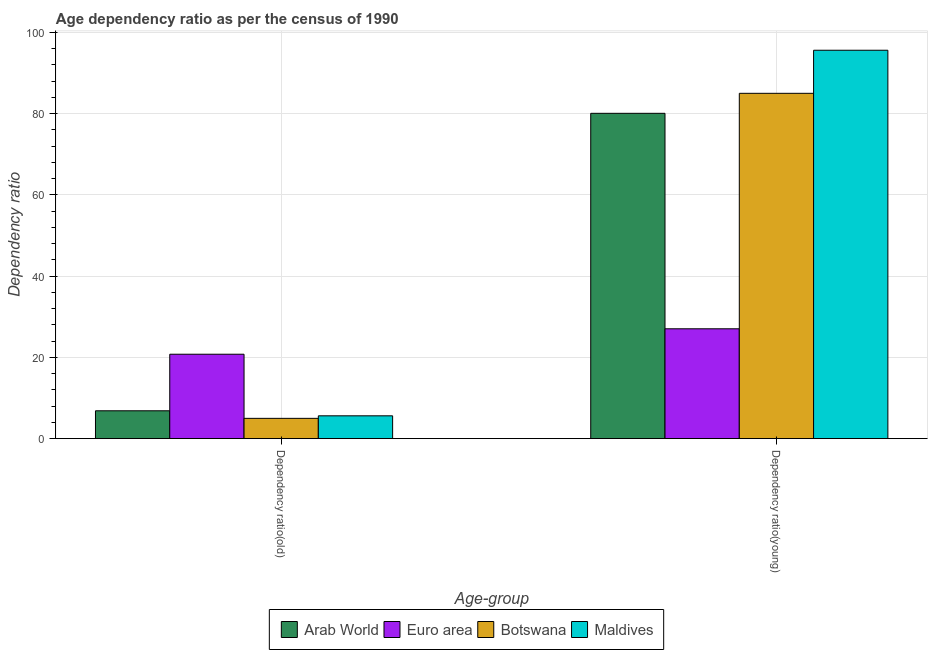How many different coloured bars are there?
Your response must be concise. 4. Are the number of bars on each tick of the X-axis equal?
Your response must be concise. Yes. How many bars are there on the 1st tick from the left?
Your response must be concise. 4. What is the label of the 2nd group of bars from the left?
Keep it short and to the point. Dependency ratio(young). What is the age dependency ratio(young) in Botswana?
Keep it short and to the point. 85.01. Across all countries, what is the maximum age dependency ratio(young)?
Ensure brevity in your answer.  95.61. Across all countries, what is the minimum age dependency ratio(young)?
Your answer should be very brief. 27.04. In which country was the age dependency ratio(old) maximum?
Provide a short and direct response. Euro area. What is the total age dependency ratio(young) in the graph?
Make the answer very short. 287.75. What is the difference between the age dependency ratio(young) in Botswana and that in Maldives?
Provide a short and direct response. -10.61. What is the difference between the age dependency ratio(old) in Botswana and the age dependency ratio(young) in Euro area?
Provide a succinct answer. -22.05. What is the average age dependency ratio(old) per country?
Your answer should be very brief. 9.56. What is the difference between the age dependency ratio(old) and age dependency ratio(young) in Botswana?
Provide a short and direct response. -80.02. In how many countries, is the age dependency ratio(young) greater than 56 ?
Your answer should be very brief. 3. What is the ratio of the age dependency ratio(old) in Arab World to that in Maldives?
Offer a terse response. 1.22. In how many countries, is the age dependency ratio(old) greater than the average age dependency ratio(old) taken over all countries?
Offer a terse response. 1. What does the 1st bar from the left in Dependency ratio(old) represents?
Offer a very short reply. Arab World. What does the 2nd bar from the right in Dependency ratio(old) represents?
Your response must be concise. Botswana. How many bars are there?
Your answer should be compact. 8. Are all the bars in the graph horizontal?
Ensure brevity in your answer.  No. How many countries are there in the graph?
Make the answer very short. 4. Does the graph contain grids?
Offer a very short reply. Yes. Where does the legend appear in the graph?
Your response must be concise. Bottom center. How many legend labels are there?
Offer a very short reply. 4. How are the legend labels stacked?
Make the answer very short. Horizontal. What is the title of the graph?
Provide a short and direct response. Age dependency ratio as per the census of 1990. Does "Lao PDR" appear as one of the legend labels in the graph?
Offer a terse response. No. What is the label or title of the X-axis?
Keep it short and to the point. Age-group. What is the label or title of the Y-axis?
Give a very brief answer. Dependency ratio. What is the Dependency ratio in Arab World in Dependency ratio(old)?
Give a very brief answer. 6.85. What is the Dependency ratio of Euro area in Dependency ratio(old)?
Give a very brief answer. 20.78. What is the Dependency ratio of Botswana in Dependency ratio(old)?
Your answer should be compact. 4.99. What is the Dependency ratio of Maldives in Dependency ratio(old)?
Provide a short and direct response. 5.61. What is the Dependency ratio of Arab World in Dependency ratio(young)?
Make the answer very short. 80.09. What is the Dependency ratio in Euro area in Dependency ratio(young)?
Offer a very short reply. 27.04. What is the Dependency ratio of Botswana in Dependency ratio(young)?
Ensure brevity in your answer.  85.01. What is the Dependency ratio in Maldives in Dependency ratio(young)?
Your answer should be very brief. 95.61. Across all Age-group, what is the maximum Dependency ratio in Arab World?
Provide a succinct answer. 80.09. Across all Age-group, what is the maximum Dependency ratio of Euro area?
Make the answer very short. 27.04. Across all Age-group, what is the maximum Dependency ratio in Botswana?
Ensure brevity in your answer.  85.01. Across all Age-group, what is the maximum Dependency ratio of Maldives?
Make the answer very short. 95.61. Across all Age-group, what is the minimum Dependency ratio of Arab World?
Ensure brevity in your answer.  6.85. Across all Age-group, what is the minimum Dependency ratio in Euro area?
Offer a terse response. 20.78. Across all Age-group, what is the minimum Dependency ratio of Botswana?
Give a very brief answer. 4.99. Across all Age-group, what is the minimum Dependency ratio in Maldives?
Your response must be concise. 5.61. What is the total Dependency ratio of Arab World in the graph?
Offer a terse response. 86.94. What is the total Dependency ratio in Euro area in the graph?
Give a very brief answer. 47.81. What is the total Dependency ratio in Botswana in the graph?
Provide a short and direct response. 90. What is the total Dependency ratio in Maldives in the graph?
Your answer should be very brief. 101.23. What is the difference between the Dependency ratio in Arab World in Dependency ratio(old) and that in Dependency ratio(young)?
Offer a terse response. -73.23. What is the difference between the Dependency ratio in Euro area in Dependency ratio(old) and that in Dependency ratio(young)?
Give a very brief answer. -6.26. What is the difference between the Dependency ratio of Botswana in Dependency ratio(old) and that in Dependency ratio(young)?
Offer a terse response. -80.02. What is the difference between the Dependency ratio in Maldives in Dependency ratio(old) and that in Dependency ratio(young)?
Keep it short and to the point. -90. What is the difference between the Dependency ratio in Arab World in Dependency ratio(old) and the Dependency ratio in Euro area in Dependency ratio(young)?
Provide a succinct answer. -20.19. What is the difference between the Dependency ratio of Arab World in Dependency ratio(old) and the Dependency ratio of Botswana in Dependency ratio(young)?
Make the answer very short. -78.16. What is the difference between the Dependency ratio in Arab World in Dependency ratio(old) and the Dependency ratio in Maldives in Dependency ratio(young)?
Your response must be concise. -88.76. What is the difference between the Dependency ratio in Euro area in Dependency ratio(old) and the Dependency ratio in Botswana in Dependency ratio(young)?
Your answer should be very brief. -64.23. What is the difference between the Dependency ratio in Euro area in Dependency ratio(old) and the Dependency ratio in Maldives in Dependency ratio(young)?
Make the answer very short. -74.84. What is the difference between the Dependency ratio of Botswana in Dependency ratio(old) and the Dependency ratio of Maldives in Dependency ratio(young)?
Your response must be concise. -90.63. What is the average Dependency ratio of Arab World per Age-group?
Give a very brief answer. 43.47. What is the average Dependency ratio in Euro area per Age-group?
Make the answer very short. 23.91. What is the average Dependency ratio in Botswana per Age-group?
Your answer should be very brief. 45. What is the average Dependency ratio of Maldives per Age-group?
Your response must be concise. 50.61. What is the difference between the Dependency ratio in Arab World and Dependency ratio in Euro area in Dependency ratio(old)?
Your answer should be very brief. -13.92. What is the difference between the Dependency ratio of Arab World and Dependency ratio of Botswana in Dependency ratio(old)?
Your response must be concise. 1.86. What is the difference between the Dependency ratio in Arab World and Dependency ratio in Maldives in Dependency ratio(old)?
Your response must be concise. 1.24. What is the difference between the Dependency ratio in Euro area and Dependency ratio in Botswana in Dependency ratio(old)?
Your answer should be compact. 15.79. What is the difference between the Dependency ratio in Euro area and Dependency ratio in Maldives in Dependency ratio(old)?
Provide a short and direct response. 15.16. What is the difference between the Dependency ratio in Botswana and Dependency ratio in Maldives in Dependency ratio(old)?
Keep it short and to the point. -0.62. What is the difference between the Dependency ratio in Arab World and Dependency ratio in Euro area in Dependency ratio(young)?
Offer a very short reply. 53.05. What is the difference between the Dependency ratio of Arab World and Dependency ratio of Botswana in Dependency ratio(young)?
Offer a terse response. -4.92. What is the difference between the Dependency ratio in Arab World and Dependency ratio in Maldives in Dependency ratio(young)?
Offer a very short reply. -15.53. What is the difference between the Dependency ratio of Euro area and Dependency ratio of Botswana in Dependency ratio(young)?
Offer a very short reply. -57.97. What is the difference between the Dependency ratio of Euro area and Dependency ratio of Maldives in Dependency ratio(young)?
Your response must be concise. -68.58. What is the difference between the Dependency ratio in Botswana and Dependency ratio in Maldives in Dependency ratio(young)?
Make the answer very short. -10.61. What is the ratio of the Dependency ratio of Arab World in Dependency ratio(old) to that in Dependency ratio(young)?
Offer a very short reply. 0.09. What is the ratio of the Dependency ratio in Euro area in Dependency ratio(old) to that in Dependency ratio(young)?
Provide a succinct answer. 0.77. What is the ratio of the Dependency ratio in Botswana in Dependency ratio(old) to that in Dependency ratio(young)?
Ensure brevity in your answer.  0.06. What is the ratio of the Dependency ratio in Maldives in Dependency ratio(old) to that in Dependency ratio(young)?
Make the answer very short. 0.06. What is the difference between the highest and the second highest Dependency ratio of Arab World?
Keep it short and to the point. 73.23. What is the difference between the highest and the second highest Dependency ratio of Euro area?
Give a very brief answer. 6.26. What is the difference between the highest and the second highest Dependency ratio of Botswana?
Give a very brief answer. 80.02. What is the difference between the highest and the second highest Dependency ratio in Maldives?
Your answer should be compact. 90. What is the difference between the highest and the lowest Dependency ratio of Arab World?
Make the answer very short. 73.23. What is the difference between the highest and the lowest Dependency ratio in Euro area?
Your answer should be compact. 6.26. What is the difference between the highest and the lowest Dependency ratio of Botswana?
Offer a terse response. 80.02. What is the difference between the highest and the lowest Dependency ratio in Maldives?
Ensure brevity in your answer.  90. 